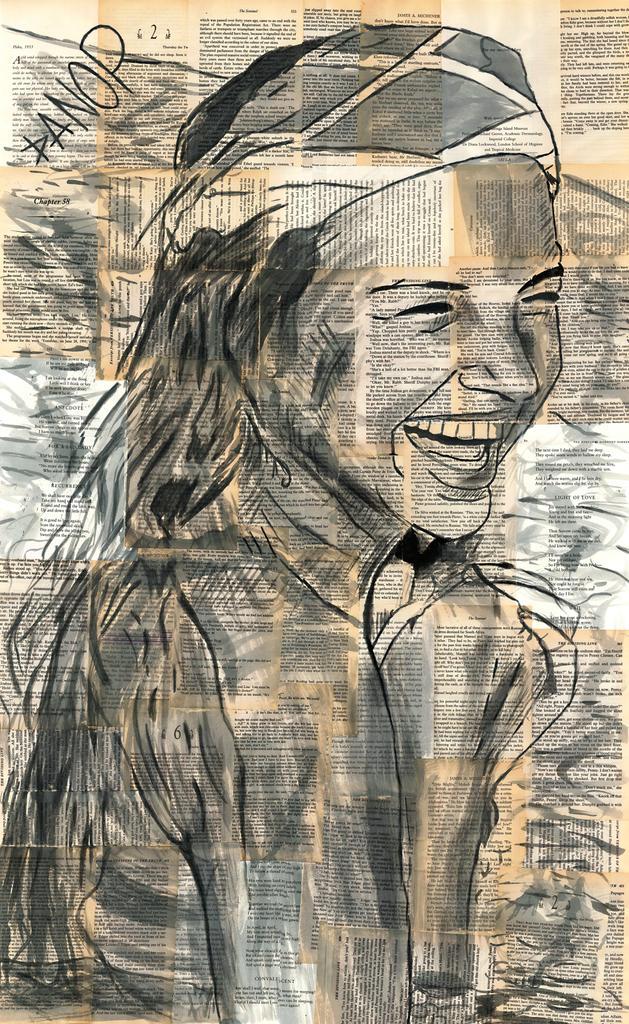How would you summarize this image in a sentence or two? In the center of the image we can see one poster. On the poster, we can see some drawing, in which we can see one woman smiling. And we can see some text on the poster. 